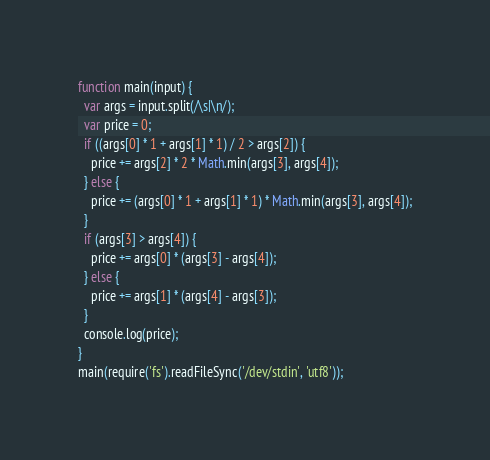<code> <loc_0><loc_0><loc_500><loc_500><_JavaScript_>function main(input) {
  var args = input.split(/\s|\n/);
  var price = 0;
  if ((args[0] * 1 + args[1] * 1) / 2 > args[2]) {
    price += args[2] * 2 * Math.min(args[3], args[4]);
  } else {
    price += (args[0] * 1 + args[1] * 1) * Math.min(args[3], args[4]);
  }
  if (args[3] > args[4]) {
    price += args[0] * (args[3] - args[4]);
  } else {
    price += args[1] * (args[4] - args[3]);
  }
  console.log(price);
}
main(require('fs').readFileSync('/dev/stdin', 'utf8'));</code> 